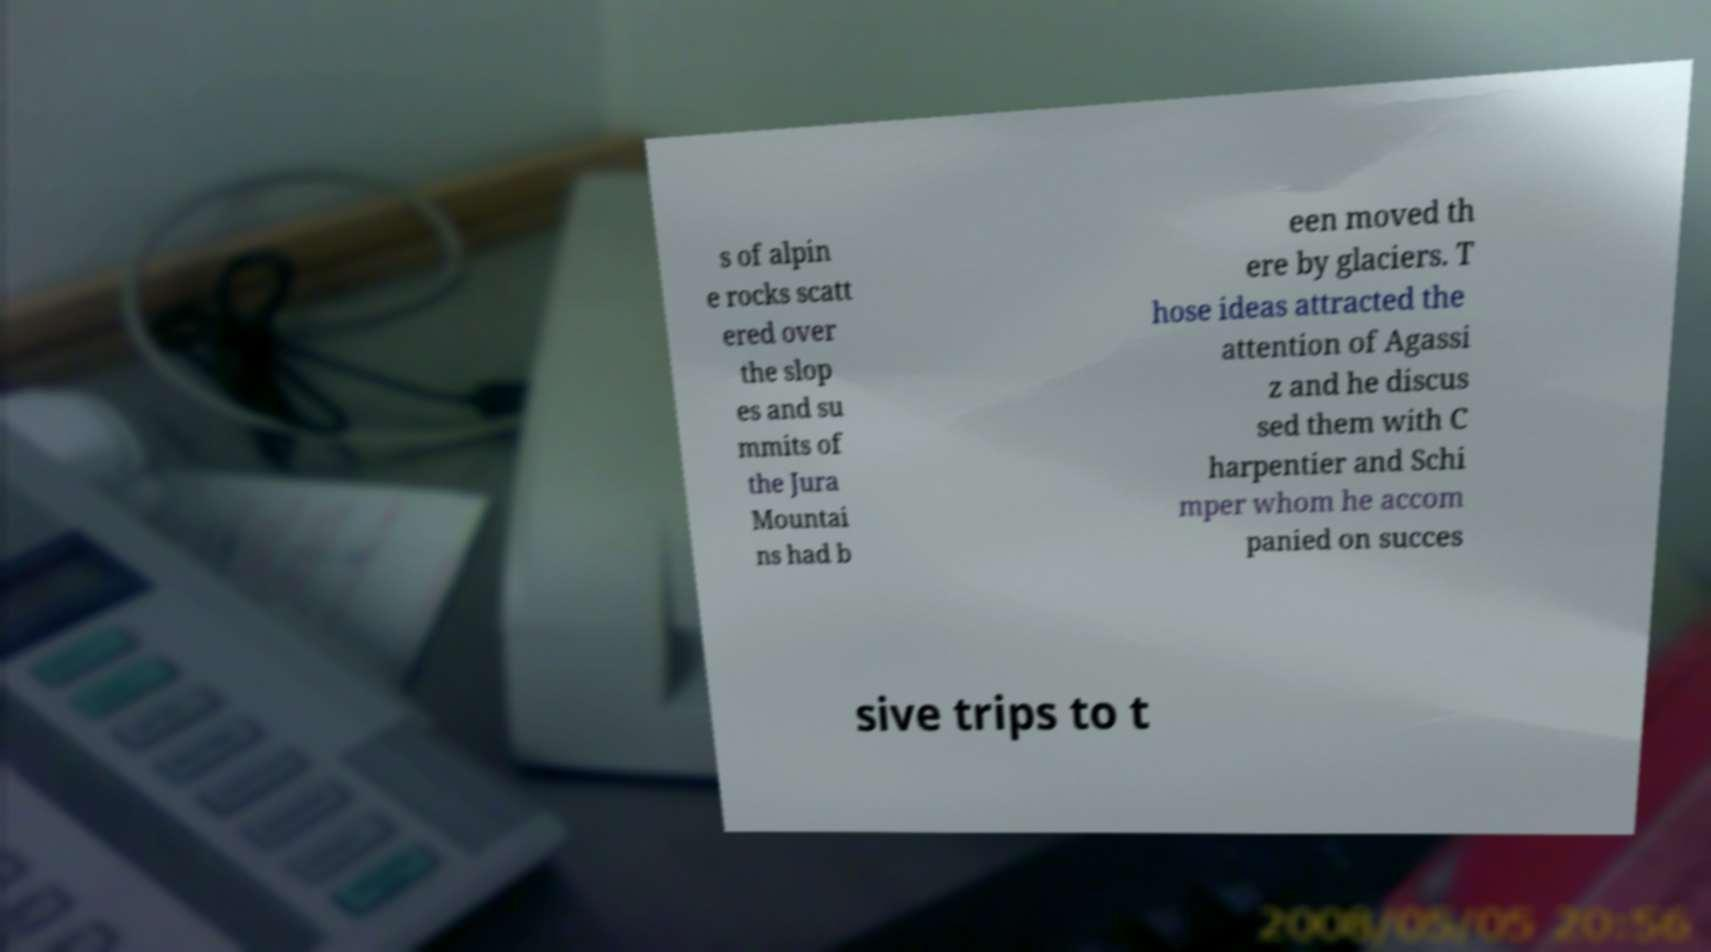Could you extract and type out the text from this image? s of alpin e rocks scatt ered over the slop es and su mmits of the Jura Mountai ns had b een moved th ere by glaciers. T hose ideas attracted the attention of Agassi z and he discus sed them with C harpentier and Schi mper whom he accom panied on succes sive trips to t 